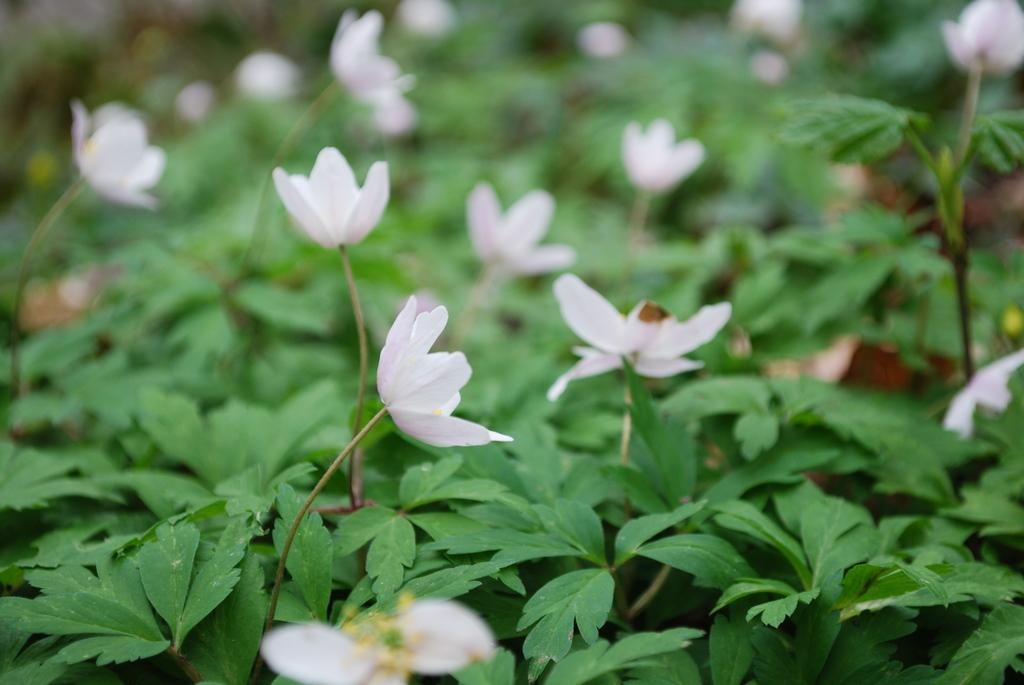What type of living organisms can be seen in the image? Plants can be seen in the image. What color are the flowers on the plants? The flowers on the plants are white. What type of truck is parked next to the plants in the image? There is no truck present in the image; it only features plants with white flowers. What type of cushion can be seen supporting the plants in the image? There is no cushion present in the image; the plants are not supported by any cushion. 